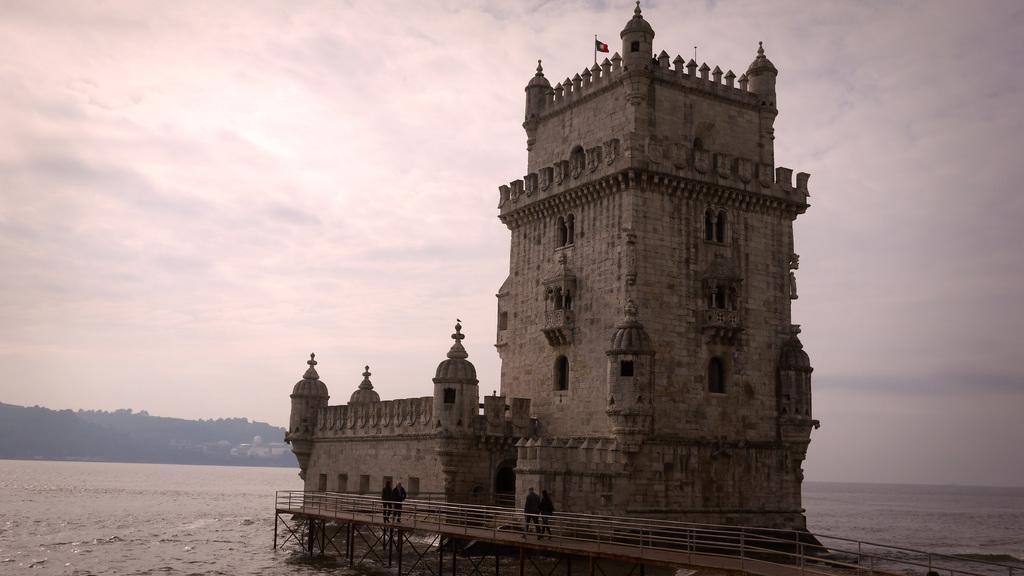Please provide a concise description of this image. In this image, we can see a Belem tower with walls, pillars, railing. Top of the image, there is a flag with pole. At the bottom, we can see few people are walking on the bridge. Here we can see the sea. Background we can see mountain, few houses and sky. 